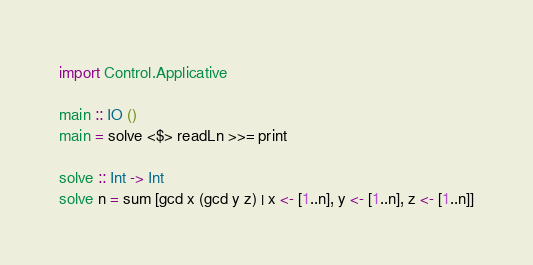<code> <loc_0><loc_0><loc_500><loc_500><_Haskell_>import Control.Applicative

main :: IO ()
main = solve <$> readLn >>= print

solve :: Int -> Int
solve n = sum [gcd x (gcd y z) | x <- [1..n], y <- [1..n], z <- [1..n]]
</code> 